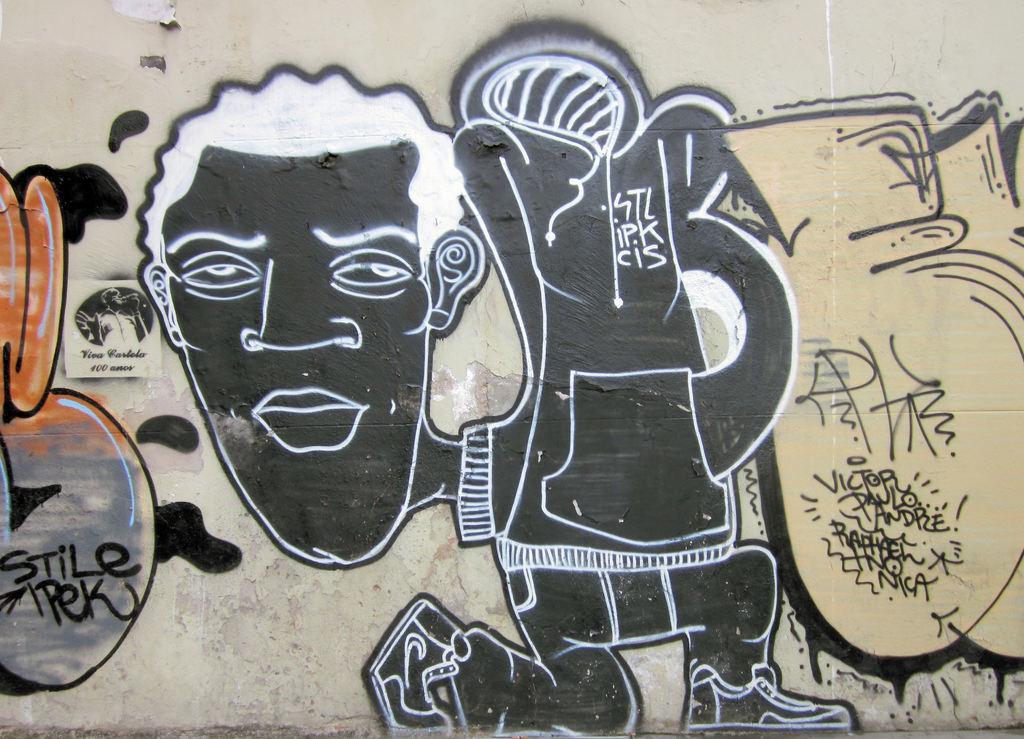In one or two sentences, can you explain what this image depicts? In this image I can see different types of paintings on the wall. I can also see something is written on the wall. 